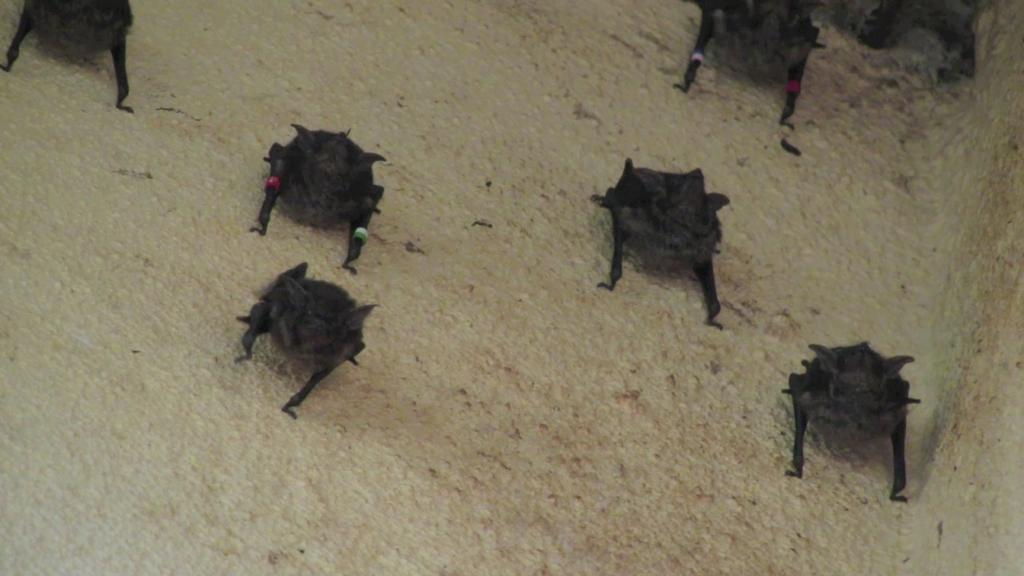What type of creatures are present in the image? There are black color insects in the image. Where are the insects located? The insects are on a path. What type of cork can be seen in the image? There is no cork present in the image; it features black color insects on a path. What scent is emitted by the insects in the image? The image does not provide information about the scent of the insects, as it only shows their appearance and location. 